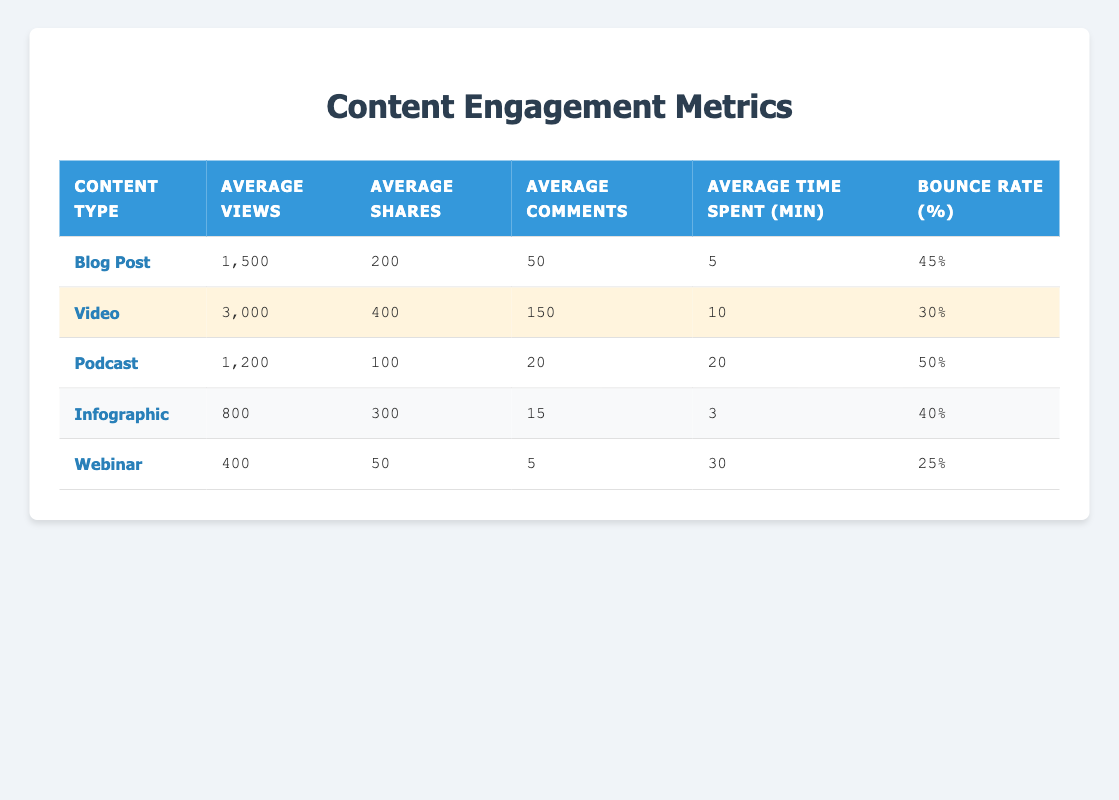What is the average number of views for a Blog Post? The table lists the average views for a Blog Post as 1500.
Answer: 1500 Which content type has the highest bounce rate? The bounce rates for each content type are: Blog Post (45%), Video (30%), Podcast (50%), Infographic (40%), and Webinar (25%). The highest bounce rate is from the Podcast at 50%.
Answer: Podcast How many more views do Videos receive compared to Infographics? The average views for Videos is 3000, and for Infographics, it is 800. To find the difference: 3000 - 800 = 2200.
Answer: 2200 What is the total number of average comments from all content types? The average comments for each content type are: Blog Post (50), Video (150), Podcast (20), Infographic (15), and Webinar (5). By summing these values: 50 + 150 + 20 + 15 + 5 = 240.
Answer: 240 Is the average time spent on a Webinar lower than on a Podcast? The average time spent on a Webinar is 30 minutes, while for a Podcast it is 20 minutes. 30 minutes is higher than 20 minutes, so the statement is false.
Answer: No Which content type had the least number of average shares, and what was that number? Examining the average shares from the table: Blog Post (200), Video (400), Podcast (100), Infographic (300), Webinar (50). The minimum is the Webinar with 50 shares.
Answer: Webinar, 50 If we consider the average time spent and the average shares, which content type has the highest ratio of average time spent to average shares? For each content type, we calculate the ratio of average time spent (minutes) to average shares: Blog Post (5/200 = 0.025), Video (10/400 = 0.025), Podcast (20/100 = 0.20), Infographic (3/300 = 0.01), Webinar (30/50 = 0.6). The highest ratio is for the Webinar at 0.6.
Answer: Webinar How many content types have an average time spent greater than 10 minutes? The average time spent for each content type is: Blog Post (5), Video (10), Podcast (20), Infographic (3), and Webinar (30). Only the Podcast (20) and Webinar (30) have times spent greater than 10 minutes, totaling 2 content types.
Answer: 2 What is the average shares per content type across all categories? The average shares for each type are: Blog Post (200), Video (400), Podcast (100), Infographic (300), and Webinar (50). Calculating the average: (200 + 400 + 100 + 300 + 50) / 5 = 210.
Answer: 210 